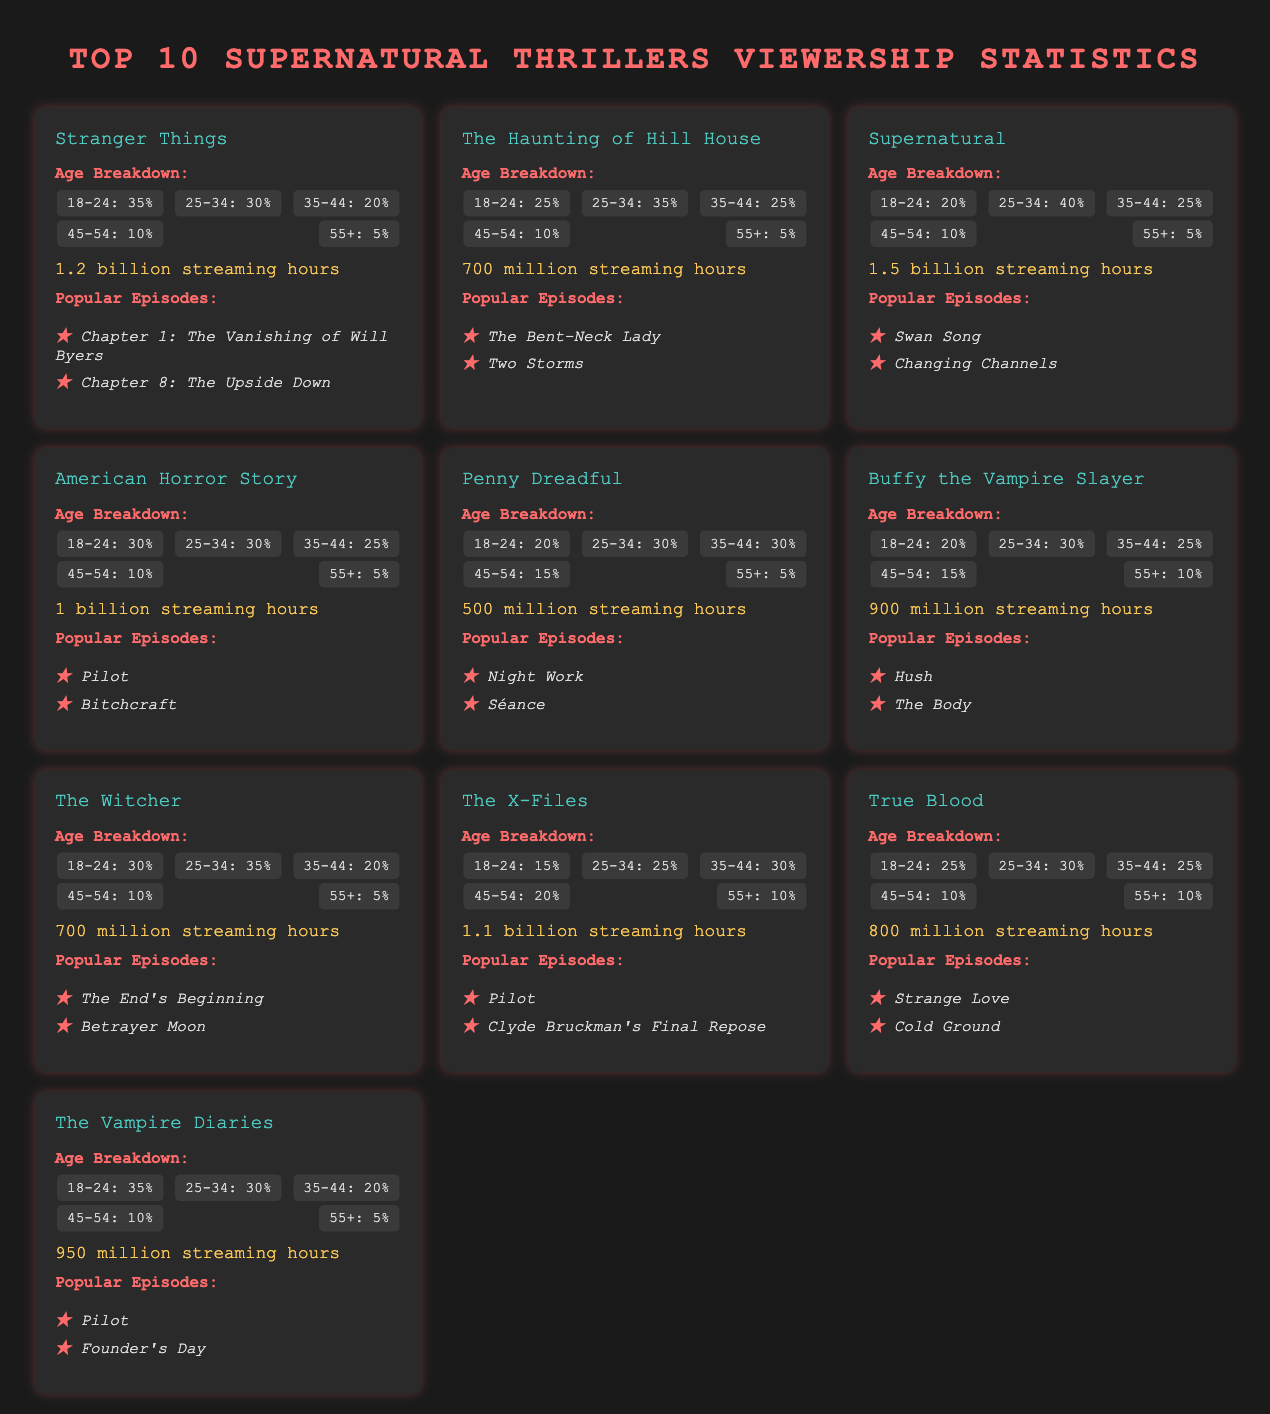What is the most popular episode of Stranger Things? The most popular episodes listed for Stranger Things are "Chapter 1: The Vanishing of Will Byers" and "Chapter 8: The Upside Down."
Answer: Chapter 1: The Vanishing of Will Byers How many streaming hours does Supernatural have? Supernatural has 1.5 billion streaming hours according to the data presented.
Answer: 1.5 billion Which age group has the highest percentage of viewers for The Haunting of Hill House? The highest percentage age group for The Haunting of Hill House is 25-34, which accounts for 35% of the viewers.
Answer: 25-34: 35% What series has 700 million streaming hours? The series that has 700 million streaming hours according to the document is The Witcher and The Haunting of Hill House.
Answer: The Witcher, The Haunting of Hill House Which series is the second most watched based on streaming hours? Based on streaming hours, Supernatural with 1.5 billion is the most watched, followed by The Haunting of Hill House with 700 million, making it the second.
Answer: The Haunting of Hill House What percentage of viewers for Buffy the Vampire Slayer are aged 45-54? The percentage of viewers aged 45-54 for Buffy the Vampire Slayer is 15%.
Answer: 15% Which supernatural thriller has the lowest viewer percentage in the 55+ age group? The series with the lowest viewer percentage in the 55+ age group is Stranger Things, which accounts for only 5%.
Answer: Stranger Things What is the total streaming hours for The Vampire Diaries? The total streaming hours recorded for The Vampire Diaries in the datasheet is 950 million.
Answer: 950 million 